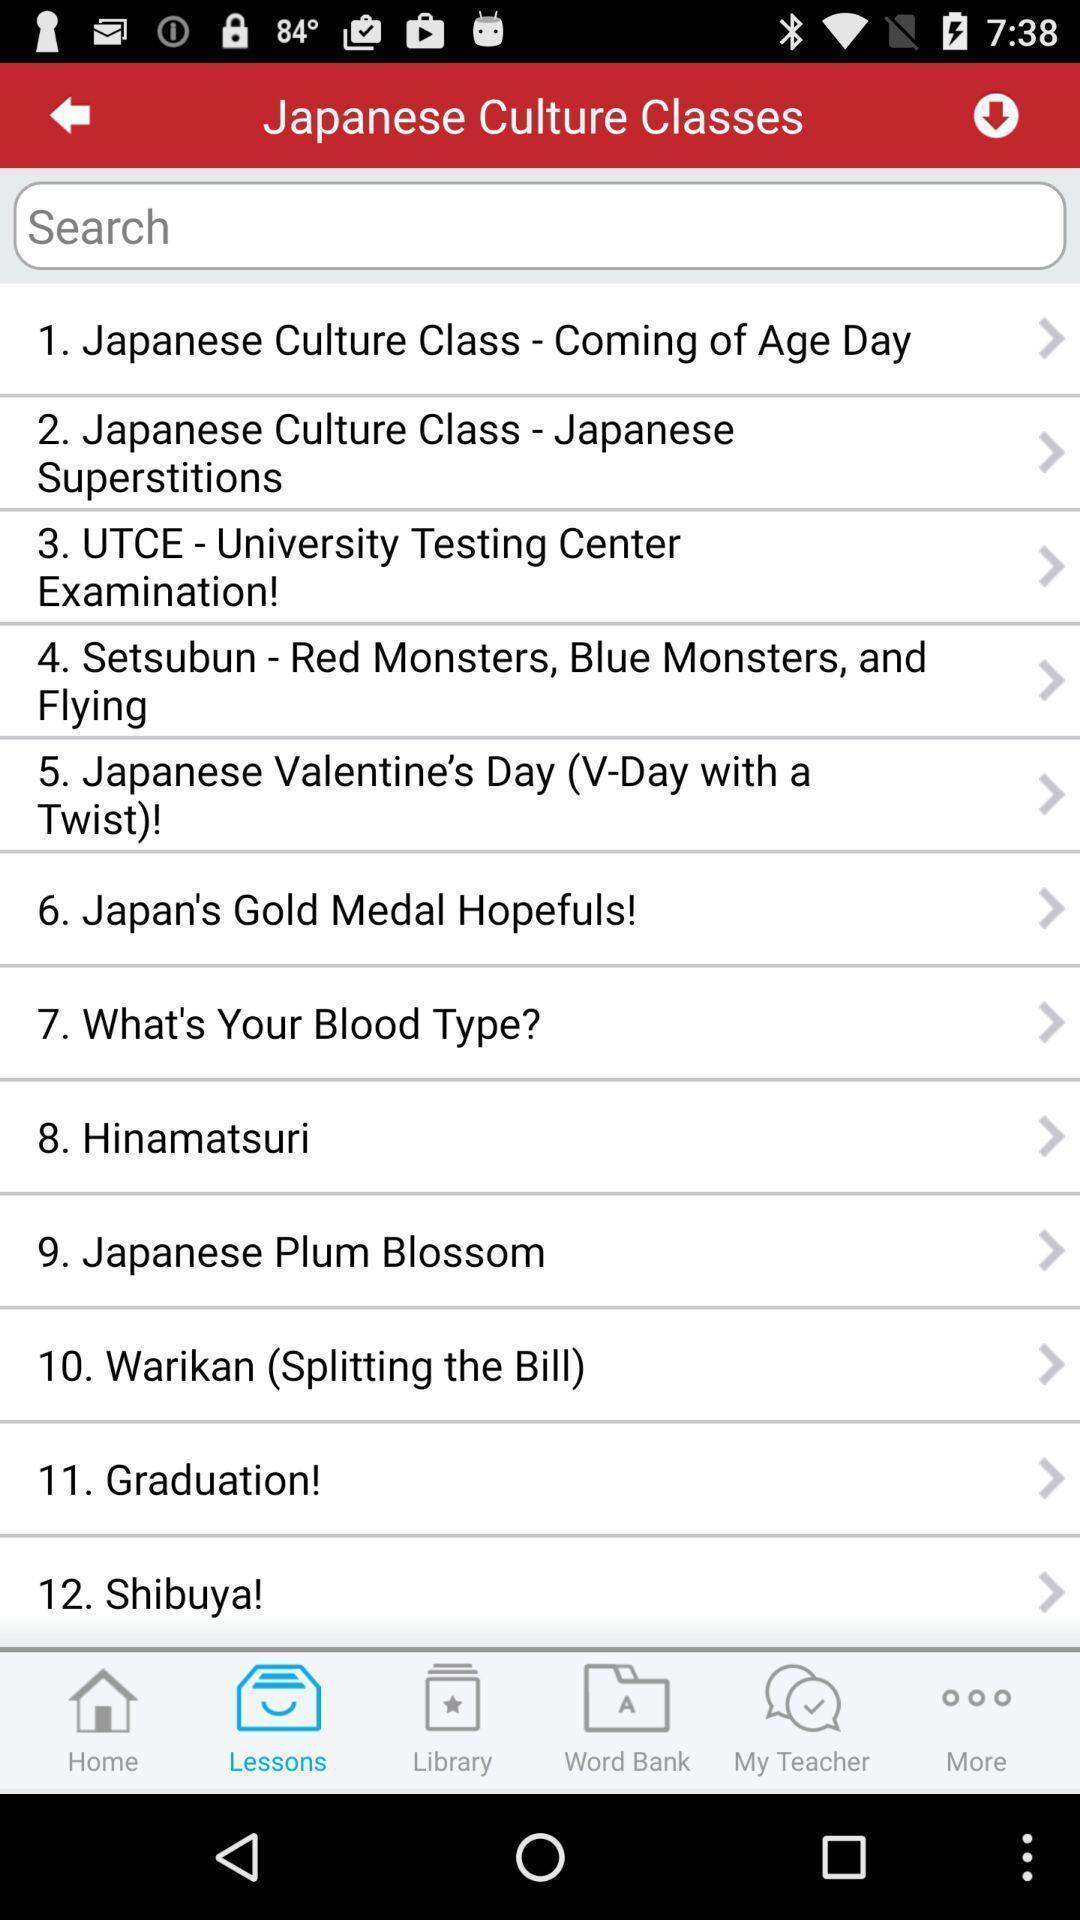What can you discern from this picture? Screen shows list of options in a learning app. 